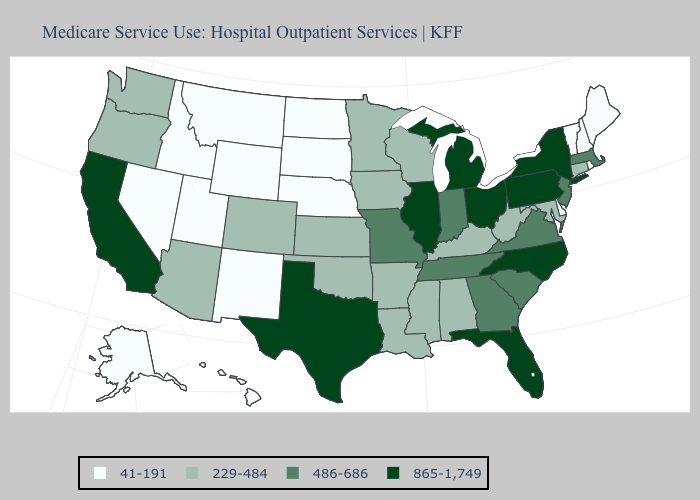Does Alabama have a lower value than Virginia?
Answer briefly. Yes. Name the states that have a value in the range 41-191?
Keep it brief. Alaska, Delaware, Hawaii, Idaho, Maine, Montana, Nebraska, Nevada, New Hampshire, New Mexico, North Dakota, Rhode Island, South Dakota, Utah, Vermont, Wyoming. Name the states that have a value in the range 865-1,749?
Write a very short answer. California, Florida, Illinois, Michigan, New York, North Carolina, Ohio, Pennsylvania, Texas. Name the states that have a value in the range 865-1,749?
Keep it brief. California, Florida, Illinois, Michigan, New York, North Carolina, Ohio, Pennsylvania, Texas. Among the states that border Wyoming , does Nebraska have the highest value?
Keep it brief. No. Name the states that have a value in the range 865-1,749?
Concise answer only. California, Florida, Illinois, Michigan, New York, North Carolina, Ohio, Pennsylvania, Texas. Does Michigan have the highest value in the USA?
Short answer required. Yes. What is the highest value in states that border Oregon?
Be succinct. 865-1,749. Does New Mexico have a lower value than South Carolina?
Keep it brief. Yes. Name the states that have a value in the range 486-686?
Quick response, please. Georgia, Indiana, Massachusetts, Missouri, New Jersey, South Carolina, Tennessee, Virginia. Does Delaware have the lowest value in the USA?
Concise answer only. Yes. Does the map have missing data?
Give a very brief answer. No. What is the lowest value in the South?
Be succinct. 41-191. Does Hawaii have a lower value than Kansas?
Short answer required. Yes. What is the value of Delaware?
Concise answer only. 41-191. 